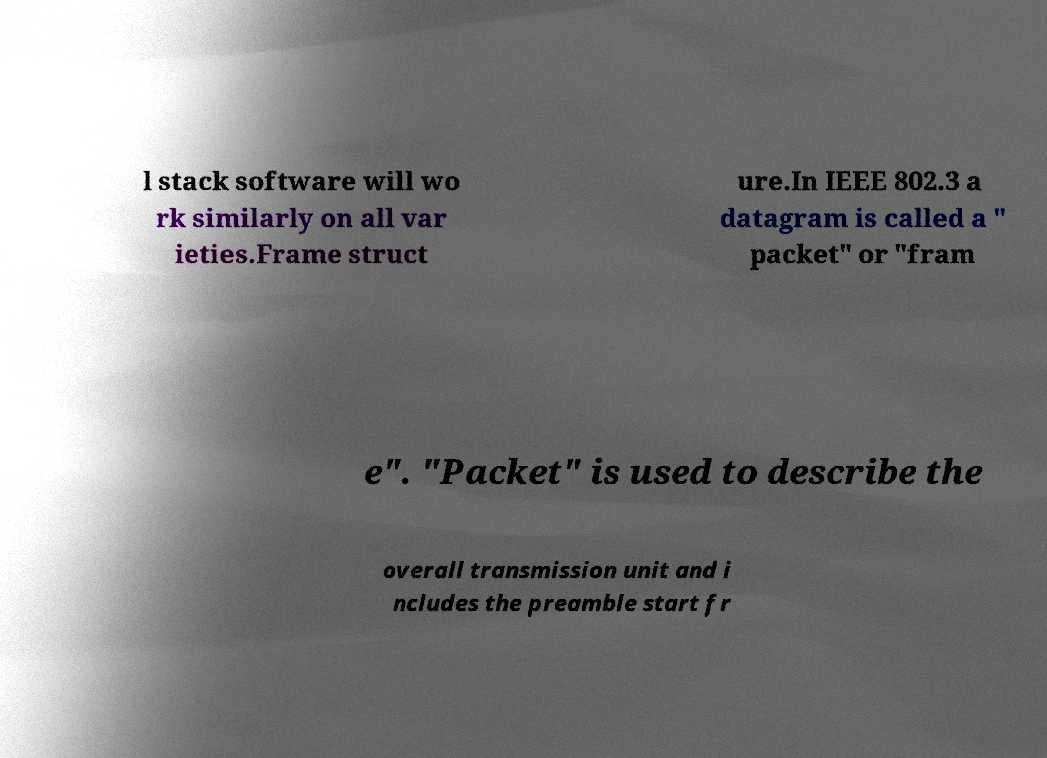Could you extract and type out the text from this image? l stack software will wo rk similarly on all var ieties.Frame struct ure.In IEEE 802.3 a datagram is called a " packet" or "fram e". "Packet" is used to describe the overall transmission unit and i ncludes the preamble start fr 